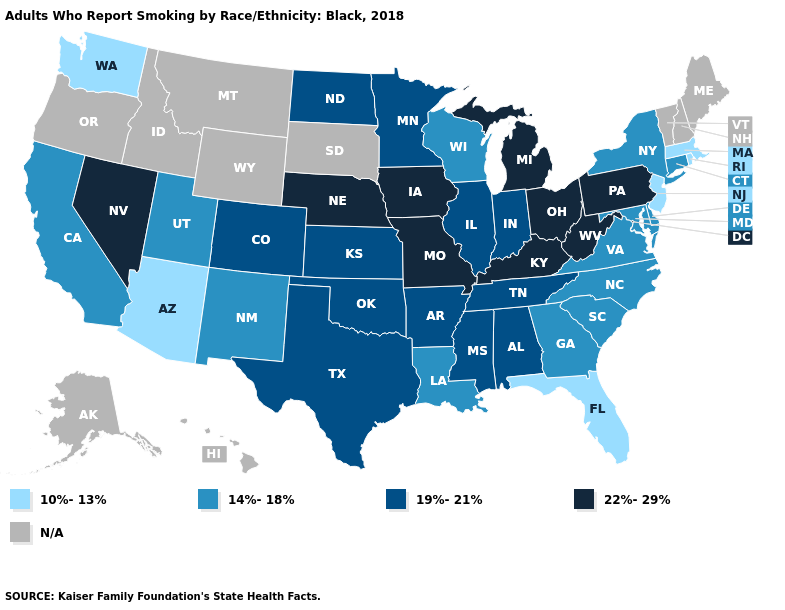Name the states that have a value in the range 10%-13%?
Quick response, please. Arizona, Florida, Massachusetts, New Jersey, Rhode Island, Washington. Name the states that have a value in the range N/A?
Keep it brief. Alaska, Hawaii, Idaho, Maine, Montana, New Hampshire, Oregon, South Dakota, Vermont, Wyoming. What is the lowest value in the USA?
Write a very short answer. 10%-13%. What is the value of Utah?
Quick response, please. 14%-18%. What is the value of California?
Write a very short answer. 14%-18%. Does Pennsylvania have the lowest value in the USA?
Quick response, please. No. How many symbols are there in the legend?
Keep it brief. 5. What is the highest value in the West ?
Concise answer only. 22%-29%. Does the first symbol in the legend represent the smallest category?
Answer briefly. Yes. What is the value of Kentucky?
Quick response, please. 22%-29%. Name the states that have a value in the range N/A?
Concise answer only. Alaska, Hawaii, Idaho, Maine, Montana, New Hampshire, Oregon, South Dakota, Vermont, Wyoming. Does California have the lowest value in the USA?
Short answer required. No. Name the states that have a value in the range 14%-18%?
Keep it brief. California, Connecticut, Delaware, Georgia, Louisiana, Maryland, New Mexico, New York, North Carolina, South Carolina, Utah, Virginia, Wisconsin. 